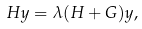Convert formula to latex. <formula><loc_0><loc_0><loc_500><loc_500>H y = \lambda ( H + G ) y ,</formula> 